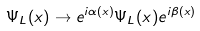Convert formula to latex. <formula><loc_0><loc_0><loc_500><loc_500>\Psi _ { L } ( x ) \to e ^ { i \alpha ( x ) } \Psi _ { L } ( x ) e ^ { i \beta ( x ) }</formula> 